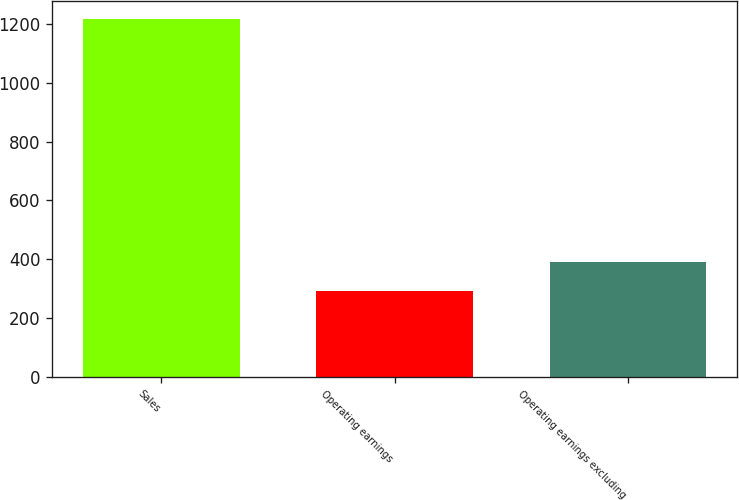Convert chart. <chart><loc_0><loc_0><loc_500><loc_500><bar_chart><fcel>Sales<fcel>Operating earnings<fcel>Operating earnings excluding<nl><fcel>1219<fcel>292<fcel>390<nl></chart> 